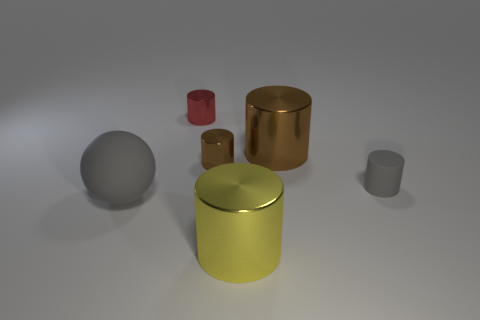Is the number of yellow things left of the large yellow cylinder less than the number of rubber cubes?
Ensure brevity in your answer.  No. The matte thing left of the tiny thing behind the large metal thing behind the gray sphere is what shape?
Provide a succinct answer. Sphere. How big is the cylinder in front of the gray cylinder?
Your answer should be very brief. Large. There is a brown thing that is the same size as the matte sphere; what shape is it?
Your answer should be compact. Cylinder. How many things are either large brown things or tiny cylinders to the right of the large brown metal cylinder?
Your answer should be compact. 2. What number of big matte spheres are behind the large shiny cylinder right of the shiny cylinder in front of the gray ball?
Keep it short and to the point. 0. The tiny thing that is made of the same material as the sphere is what color?
Give a very brief answer. Gray. Do the thing in front of the gray ball and the gray sphere have the same size?
Offer a very short reply. Yes. What number of objects are either small rubber cylinders or big cyan things?
Offer a terse response. 1. What material is the small object that is on the right side of the metal cylinder that is in front of the rubber object to the left of the small red metal thing made of?
Provide a succinct answer. Rubber. 